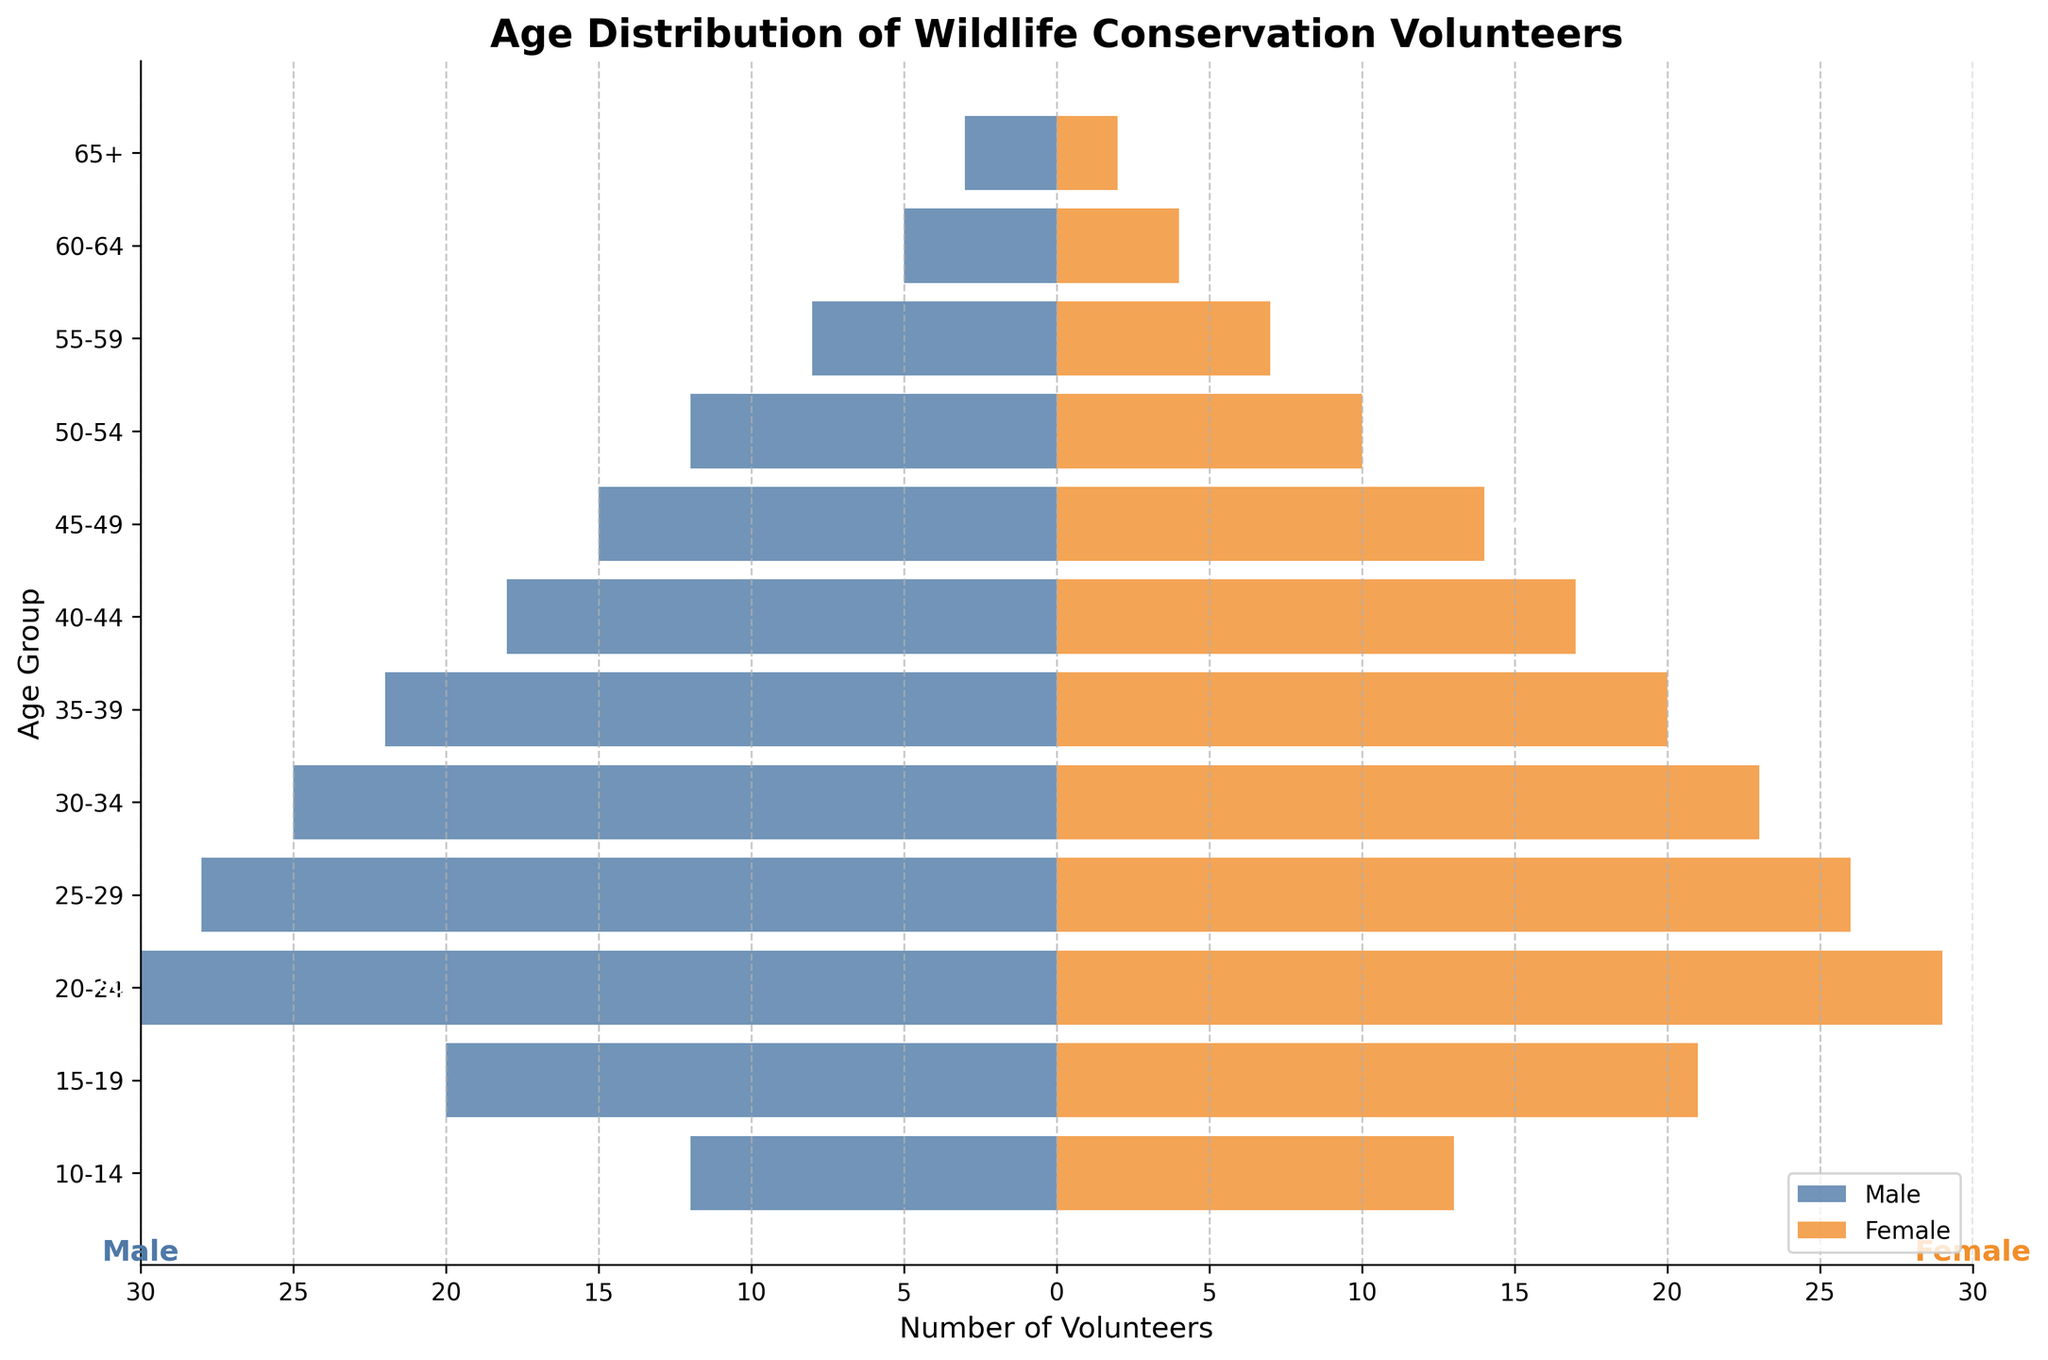How many age groups are represented in the figure? The figure displays the y-axis with labels for different age groups. Counting the number of distinct age group labels gives the answer.
Answer: 12 Which age group has the highest number of female volunteers? By examining the lengths of the orange bars (representing females) in each age group, the 20-24 age group has the longest bar, indicating the highest number.
Answer: 20-24 What's the total number of male volunteers in the 30-39 age groups combined? Add the number of male volunteers in the 30-34 and 35-39 groups: (-25) + (-22). Since the values are negative, sum them as positives.
Answer: 47 What's the average number of volunteers in the 15-19 age group? Total number of volunteers (both male and female) in the 15-19 group: 20 (male) + 21 (female). Average = (20 + 21) / 2.
Answer: 20.5 Compare the number of male and female volunteers in the 50-54 age group. Which gender has more volunteers, and by how many? Male volunteers: 12, Female volunteers: 10. Difference = 12 - 10.
Answer: Males by 2 What is the trend of volunteer numbers as age increases? Observing the lengths of bars for both genders shows that the number of volunteers generally decreases as age increases.
Answer: Decreasing Which gender has more total volunteers in the age group 45-49? Male volunteers: 15, Female volunteers: 14.
Answer: Male What is the sum of male volunteers in the age groups 55-64? Add male volunteers in age groups 55-59 and 60-64: (-8) + (-5). Since values are negative, sum them as positives.
Answer: 13 Are there more female or male volunteers across all age groups? Summing the female and male values across all age groups and comparing: Female: 226, Male: 198.
Answer: Female 